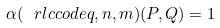Convert formula to latex. <formula><loc_0><loc_0><loc_500><loc_500>\alpha ( \ r l c c o d e { q , n , m } ) ( P , Q ) = 1</formula> 